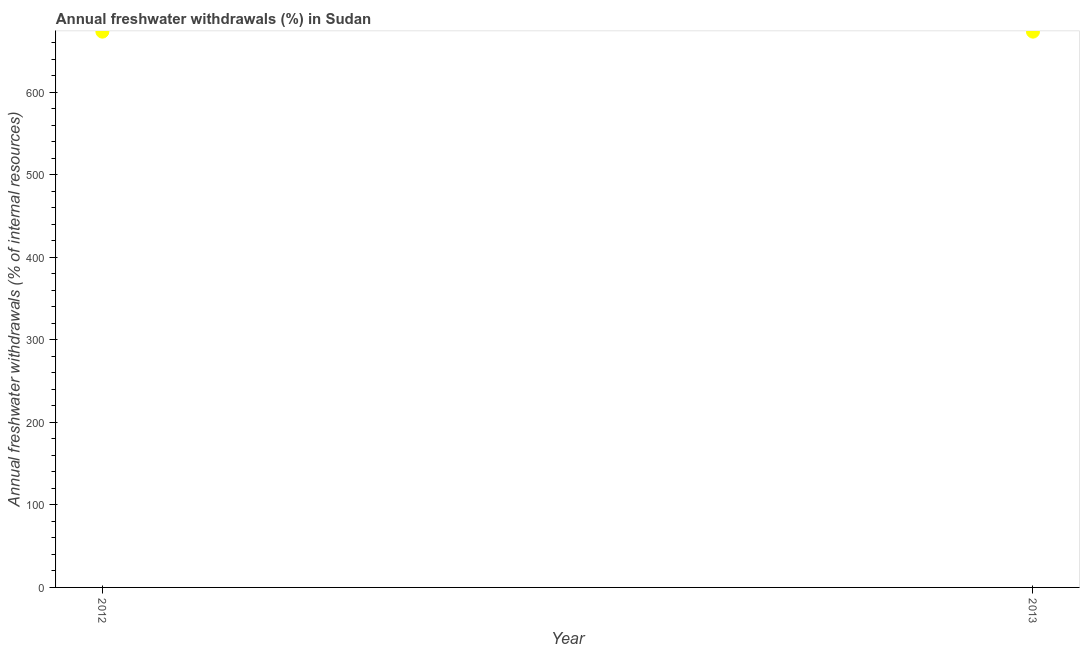What is the annual freshwater withdrawals in 2012?
Your response must be concise. 673.25. Across all years, what is the maximum annual freshwater withdrawals?
Offer a very short reply. 673.25. Across all years, what is the minimum annual freshwater withdrawals?
Give a very brief answer. 673.25. In which year was the annual freshwater withdrawals maximum?
Offer a terse response. 2012. What is the sum of the annual freshwater withdrawals?
Your answer should be very brief. 1346.5. What is the difference between the annual freshwater withdrawals in 2012 and 2013?
Offer a very short reply. 0. What is the average annual freshwater withdrawals per year?
Your answer should be compact. 673.25. What is the median annual freshwater withdrawals?
Make the answer very short. 673.25. In how many years, is the annual freshwater withdrawals greater than 540 %?
Provide a succinct answer. 2. Is the annual freshwater withdrawals in 2012 less than that in 2013?
Offer a terse response. No. Does the annual freshwater withdrawals monotonically increase over the years?
Give a very brief answer. No. How many years are there in the graph?
Your answer should be very brief. 2. What is the title of the graph?
Offer a terse response. Annual freshwater withdrawals (%) in Sudan. What is the label or title of the Y-axis?
Provide a short and direct response. Annual freshwater withdrawals (% of internal resources). What is the Annual freshwater withdrawals (% of internal resources) in 2012?
Offer a very short reply. 673.25. What is the Annual freshwater withdrawals (% of internal resources) in 2013?
Provide a short and direct response. 673.25. What is the difference between the Annual freshwater withdrawals (% of internal resources) in 2012 and 2013?
Make the answer very short. 0. What is the ratio of the Annual freshwater withdrawals (% of internal resources) in 2012 to that in 2013?
Give a very brief answer. 1. 